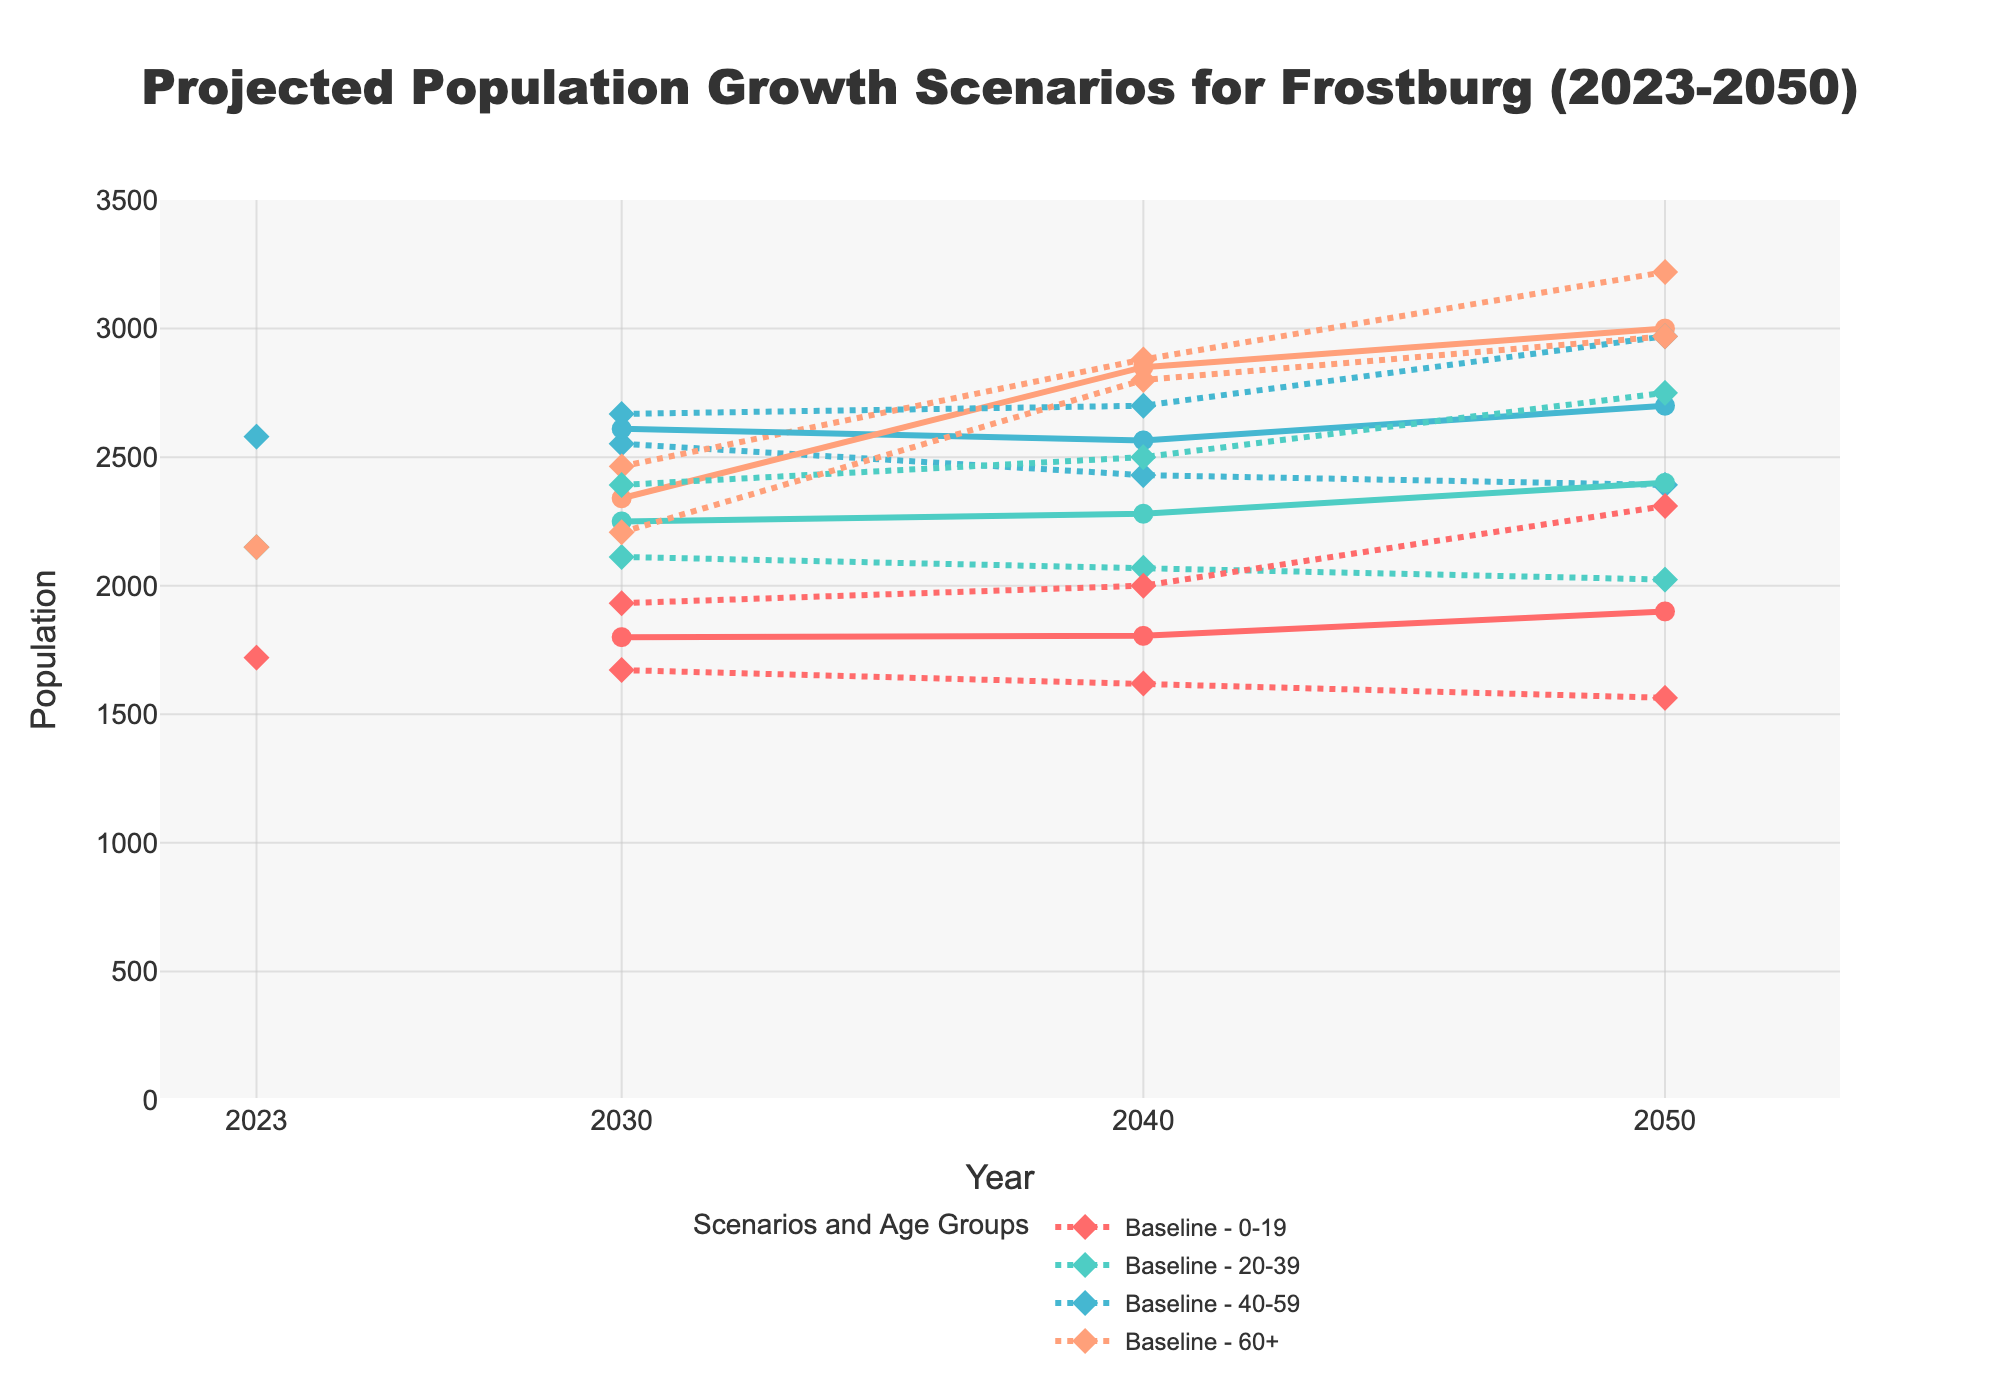What's the title of the figure? The title of the figure is found at the top and provides a summary of the content displayed in the chart. In this case, it states the projected population growth scenarios for Frostburg from 2023 to 2050.
Answer: Projected Population Growth Scenarios for Frostburg (2023-2050) How many growth scenarios are displayed in the figure? The legend of the figure lists different scenarios. By counting them, you can determine how many unique growth scenarios are included.
Answer: 3 Which age group in the High Growth scenario has the highest projected population in 2050? Look at the data points for the High Growth scenario in 2050 and compare the values of each age group. The one with the highest value is the answer.
Answer: 60+ What is the total population for the Baseline scenario in 2023? Refer to the annotation or the value for the Baseline scenario line in the year 2023. The annotation shows both the scenario and its corresponding total population.
Answer: 8600 Compare the population of the 20-39 age group in the Medium Growth scenario between 2030 and 2040. Which year has a higher population? Find the data points for the 20-39 age group in the Medium Growth scenario for both 2030 and 2040 and compare the values.
Answer: 2040 Which scenario and age group combination has the lowest projected population in 2040? Assess the figure for all scenario and age group combinations in 2040, identify the combination with the smallest value.
Answer: Low Growth, 0-19 